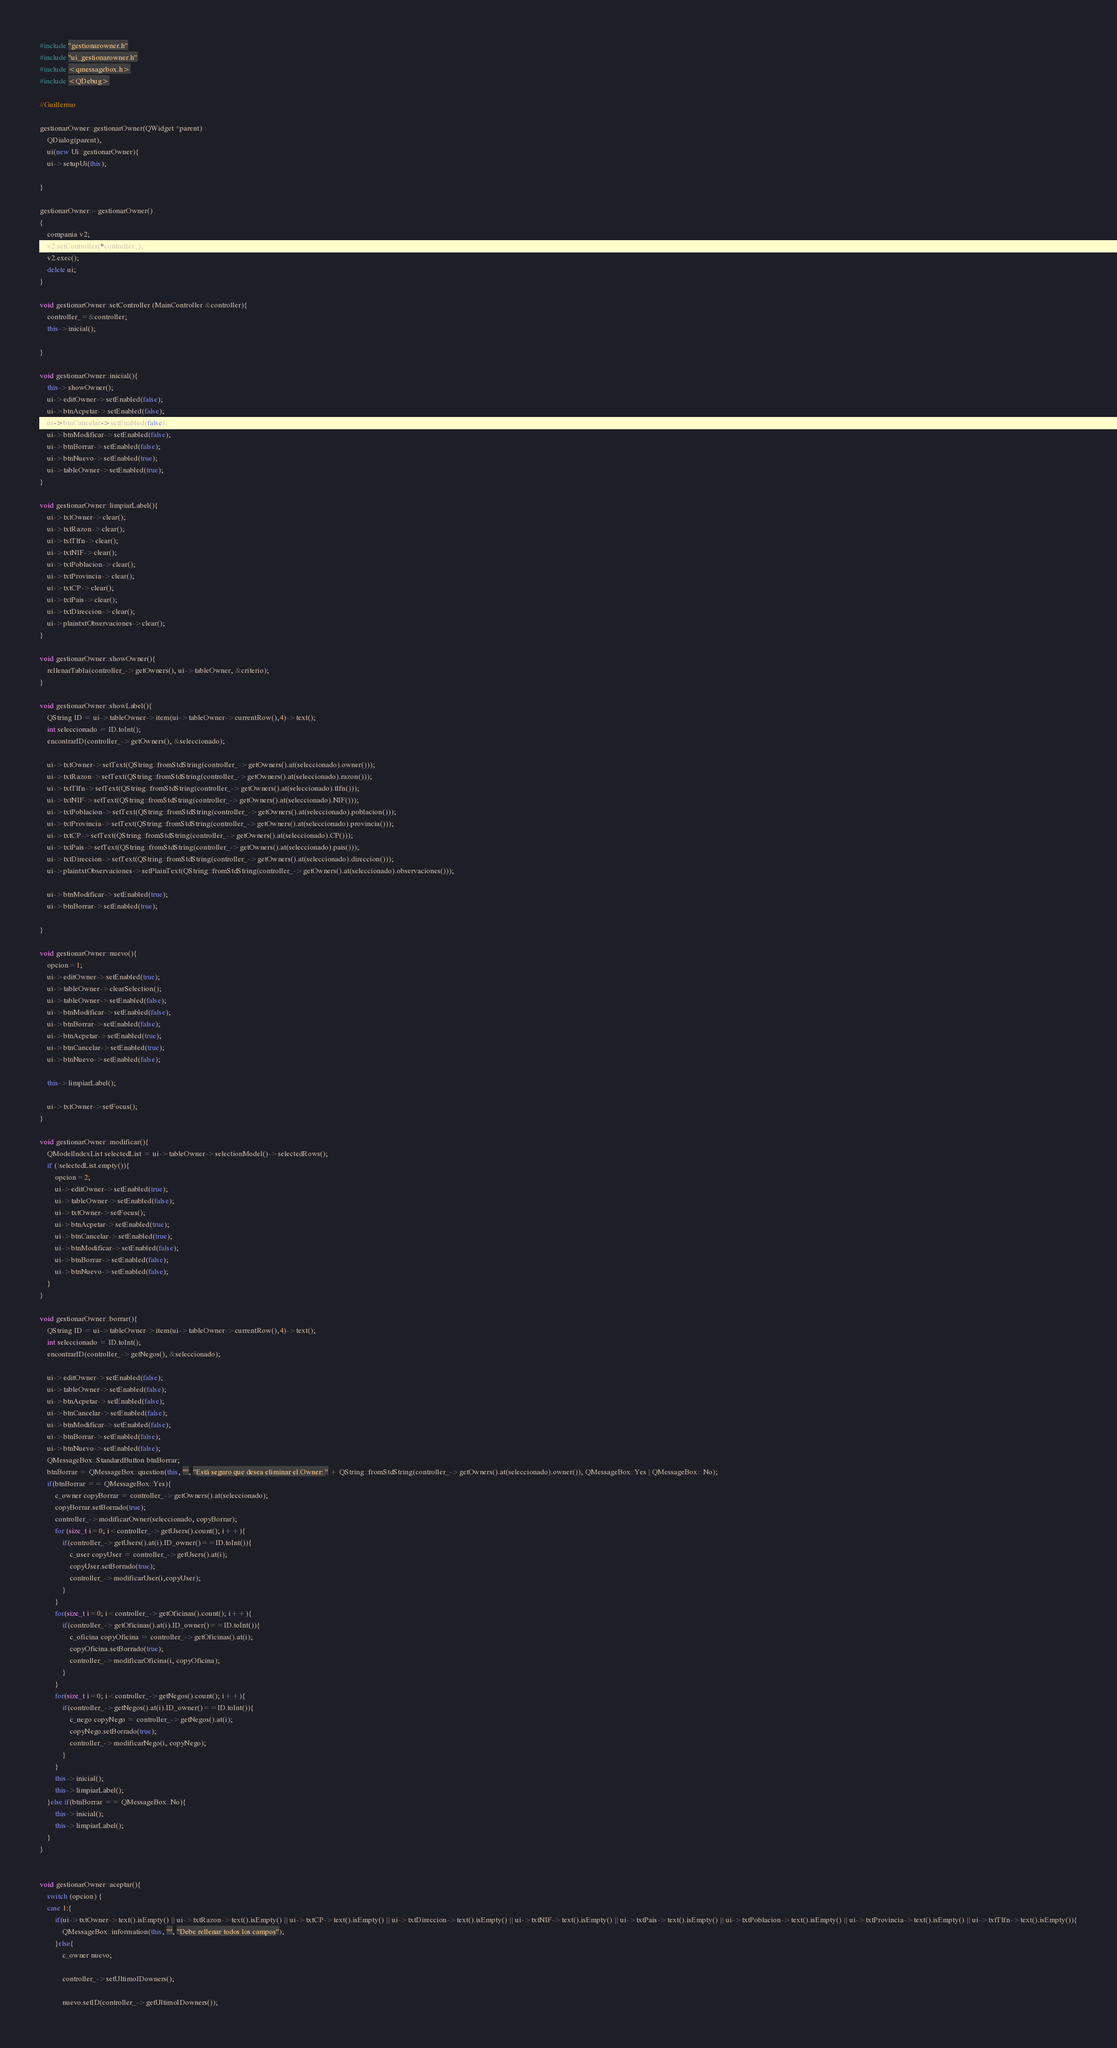Convert code to text. <code><loc_0><loc_0><loc_500><loc_500><_C++_>#include "gestionarowner.h"
#include "ui_gestionarowner.h"
#include <qmessagebox.h>
#include <QDebug>

//Guillermo

gestionarOwner::gestionarOwner(QWidget *parent) :
    QDialog(parent),
    ui(new Ui::gestionarOwner){
    ui->setupUi(this);

}

gestionarOwner::~gestionarOwner()
{
    compania v2;
    v2.setController(*controller_);
    v2.exec();
    delete ui;
}

void gestionarOwner::setController (MainController &controller){
    controller_=&controller;
    this->inicial();

}

void gestionarOwner::inicial(){
    this->showOwner();
    ui->editOwner->setEnabled(false);
    ui->btnAcpetar->setEnabled(false);
    ui->btnCancelar->setEnabled(false);
    ui->btnModificar->setEnabled(false);
    ui->btnBorrar->setEnabled(false);
    ui->btnNuevo->setEnabled(true);
    ui->tableOwner->setEnabled(true);
}

void gestionarOwner::limpiarLabel(){
    ui->txtOwner->clear();
    ui->txtRazon->clear();
    ui->txtTlfn->clear();
    ui->txtNIF->clear();
    ui->txtPoblacion->clear();
    ui->txtProvincia->clear();
    ui->txtCP->clear();
    ui->txtPais->clear();
    ui->txtDireccion->clear();
    ui->plaintxtObservaciones->clear();
}

void gestionarOwner::showOwner(){
    rellenarTabla(controller_->getOwners(), ui->tableOwner, &criterio);
}

void gestionarOwner::showLabel(){
    QString ID = ui->tableOwner->item(ui->tableOwner->currentRow(),4)->text();
    int seleccionado = ID.toInt();
    encontrarID(controller_->getOwners(), &seleccionado);

    ui->txtOwner->setText(QString::fromStdString(controller_->getOwners().at(seleccionado).owner()));
    ui->txtRazon->setText(QString::fromStdString(controller_->getOwners().at(seleccionado).razon()));
    ui->txtTlfn->setText(QString::fromStdString(controller_->getOwners().at(seleccionado).tlfn()));
    ui->txtNIF->setText(QString::fromStdString(controller_->getOwners().at(seleccionado).NIF()));
    ui->txtPoblacion->setText(QString::fromStdString(controller_->getOwners().at(seleccionado).poblacion()));
    ui->txtProvincia->setText(QString::fromStdString(controller_->getOwners().at(seleccionado).provincia()));
    ui->txtCP->setText(QString::fromStdString(controller_->getOwners().at(seleccionado).CP()));
    ui->txtPais->setText(QString::fromStdString(controller_->getOwners().at(seleccionado).pais()));
    ui->txtDireccion->setText(QString::fromStdString(controller_->getOwners().at(seleccionado).direccion()));
    ui->plaintxtObservaciones->setPlainText(QString::fromStdString(controller_->getOwners().at(seleccionado).observaciones()));

    ui->btnModificar->setEnabled(true);
    ui->btnBorrar->setEnabled(true);

}

void gestionarOwner::nuevo(){
    opcion=1;
    ui->editOwner->setEnabled(true);
    ui->tableOwner->clearSelection();
    ui->tableOwner->setEnabled(false);
    ui->btnModificar->setEnabled(false);
    ui->btnBorrar->setEnabled(false);
    ui->btnAcpetar->setEnabled(true);
    ui->btnCancelar->setEnabled(true);
    ui->btnNuevo->setEnabled(false);

    this->limpiarLabel();

    ui->txtOwner->setFocus();
}

void gestionarOwner::modificar(){
    QModelIndexList selectedList = ui->tableOwner->selectionModel()->selectedRows();
    if (!selectedList.empty()){
        opcion=2;
        ui->editOwner->setEnabled(true);
        ui->tableOwner->setEnabled(false);
        ui->txtOwner->setFocus();
        ui->btnAcpetar->setEnabled(true);
        ui->btnCancelar->setEnabled(true);
        ui->btnModificar->setEnabled(false);
        ui->btnBorrar->setEnabled(false);
        ui->btnNuevo->setEnabled(false);
    }
}

void gestionarOwner::borrar(){
    QString ID = ui->tableOwner->item(ui->tableOwner->currentRow(),4)->text();
    int seleccionado = ID.toInt();
    encontrarID(controller_->getNegos(), &seleccionado);

    ui->editOwner->setEnabled(false);
    ui->tableOwner->setEnabled(false);
    ui->btnAcpetar->setEnabled(false);
    ui->btnCancelar->setEnabled(false);
    ui->btnModificar->setEnabled(false);
    ui->btnBorrar->setEnabled(false);
    ui->btnNuevo->setEnabled(false);
    QMessageBox::StandardButton btnBorrar;
    btnBorrar = QMessageBox::question(this, "", "Está seguro que desea eliminar el Owner: " + QString::fromStdString(controller_->getOwners().at(seleccionado).owner()), QMessageBox::Yes | QMessageBox:: No);
    if(btnBorrar == QMessageBox::Yes){
        c_owner copyBorrar = controller_->getOwners().at(seleccionado);
        copyBorrar.setBorrado(true);
        controller_->modificarOwner(seleccionado, copyBorrar);
        for (size_t i=0; i<controller_->getUsers().count(); i++){
            if(controller_->getUsers().at(i).ID_owner()==ID.toInt()){
                c_user copyUser = controller_->getUsers().at(i);
                copyUser.setBorrado(true);
                controller_->modificarUser(i,copyUser);
            }
        }
        for(size_t i=0; i<controller_->getOficinas().count(); i++){
            if(controller_->getOficinas().at(i).ID_owner()==ID.toInt()){
                c_oficina copyOficina = controller_->getOficinas().at(i);
                copyOficina.setBorrado(true);
                controller_->modificarOficina(i, copyOficina);
            }
        }
        for(size_t i=0; i<controller_->getNegos().count(); i++){
            if(controller_->getNegos().at(i).ID_owner()==ID.toInt()){
                c_nego copyNego = controller_->getNegos().at(i);
                copyNego.setBorrado(true);
                controller_->modificarNego(i, copyNego);
            }
        }
        this->inicial();
        this->limpiarLabel();
    }else if(btnBorrar == QMessageBox::No){
        this->inicial();
        this->limpiarLabel();
    }
}


void gestionarOwner::aceptar(){
    switch (opcion) {
    case 1:{
        if(ui->txtOwner->text().isEmpty() || ui->txtRazon->text().isEmpty() || ui->txtCP->text().isEmpty() || ui->txtDireccion->text().isEmpty() || ui->txtNIF->text().isEmpty() || ui->txtPais->text().isEmpty() || ui->txtPoblacion->text().isEmpty() || ui->txtProvincia->text().isEmpty() || ui->txtTlfn->text().isEmpty()){
            QMessageBox::information(this, "", "Debe rellenar todos los campos");
        }else{
            c_owner nuevo;

            controller_->setUltimoIDowners();

            nuevo.setID(controller_->getUltimoIDowners());</code> 